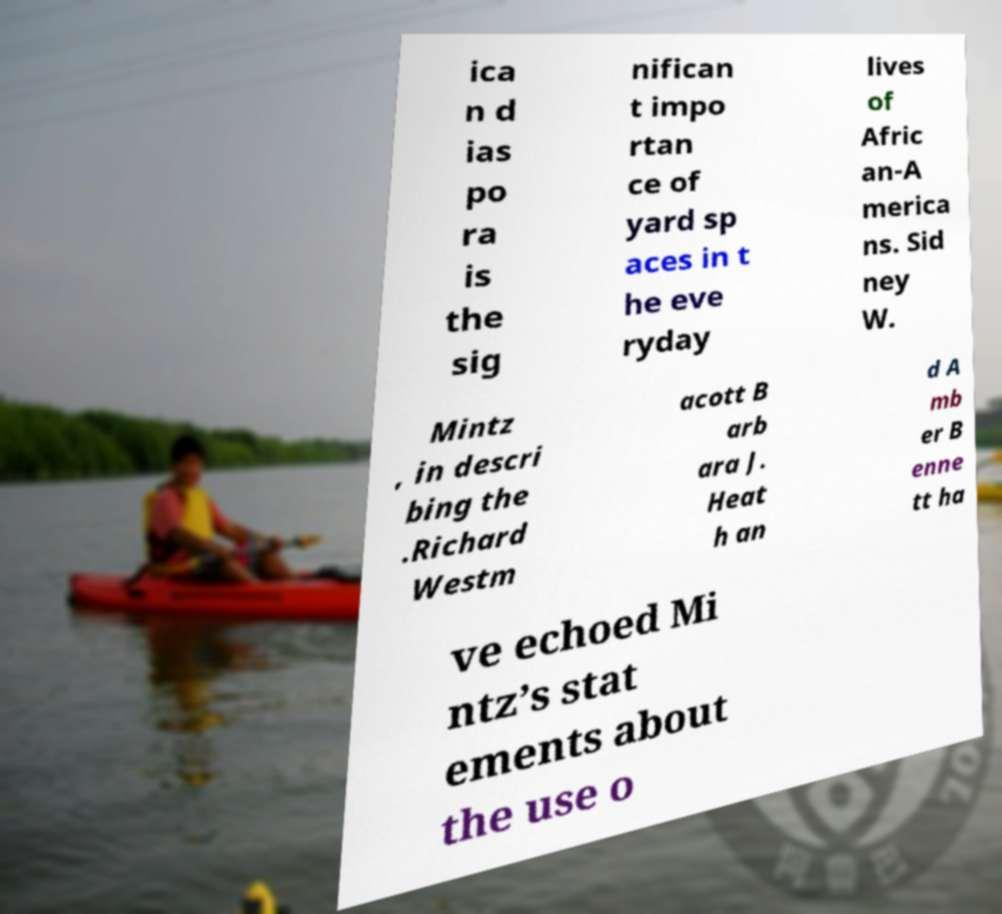Please identify and transcribe the text found in this image. ica n d ias po ra is the sig nifican t impo rtan ce of yard sp aces in t he eve ryday lives of Afric an-A merica ns. Sid ney W. Mintz , in descri bing the .Richard Westm acott B arb ara J. Heat h an d A mb er B enne tt ha ve echoed Mi ntz’s stat ements about the use o 